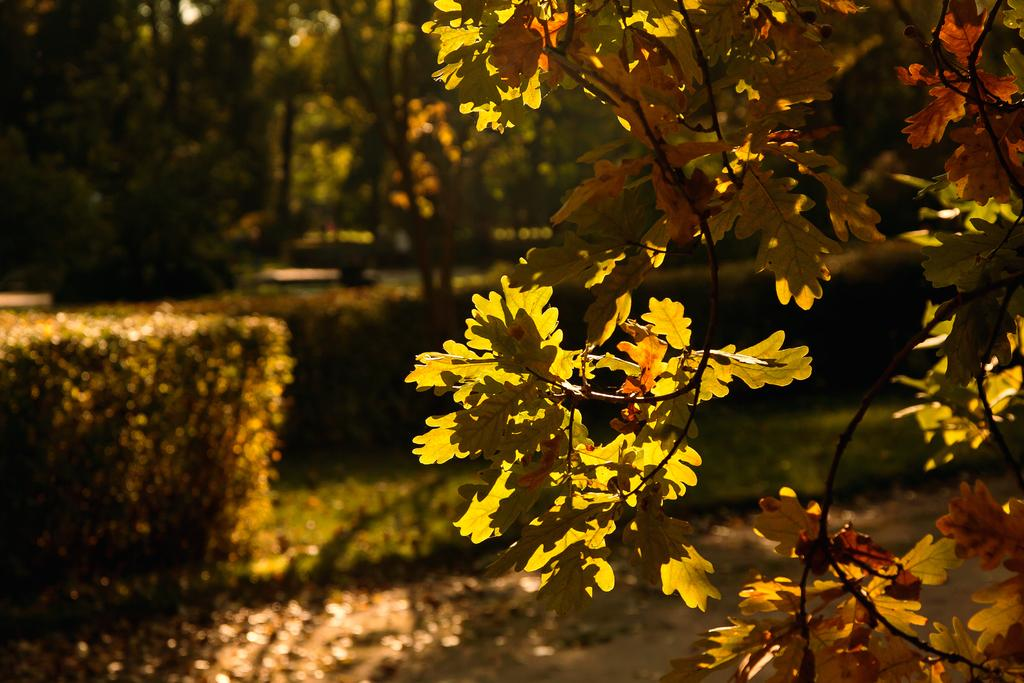What type of vegetation can be seen in the image? There are plants and trees in the image. Where are the plants and trees located? The plants and trees are on a grassland. Can you describe the branches with leaves in the image? There are branches with leaves on the right side of the image. What type of reward is the kitty receiving in the image? There is no kitty present in the image, and therefore no reward can be observed. Where is the office located in the image? There is no office present in the image; it features plants, trees, and a grassland. 